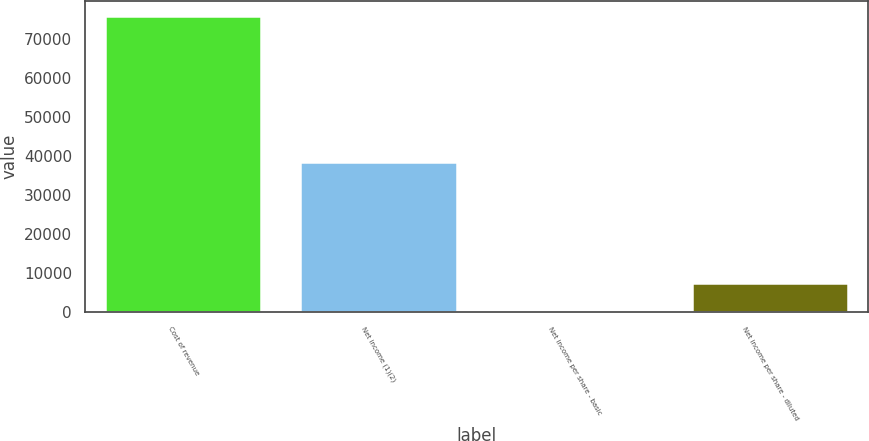Convert chart. <chart><loc_0><loc_0><loc_500><loc_500><bar_chart><fcel>Cost of revenue<fcel>Net income (1)(2)<fcel>Net income per share - basic<fcel>Net income per share - diluted<nl><fcel>76048<fcel>38477<fcel>0.14<fcel>7604.93<nl></chart> 